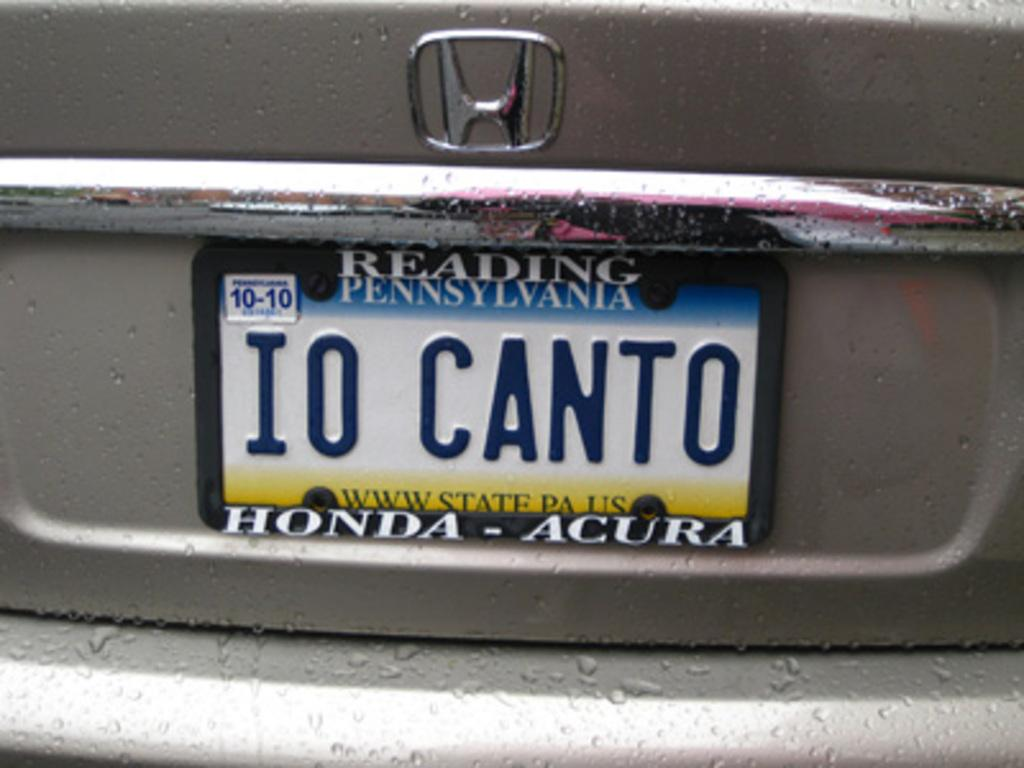<image>
Render a clear and concise summary of the photo. White license plate from Pennsylvania which says IO CANTO. 